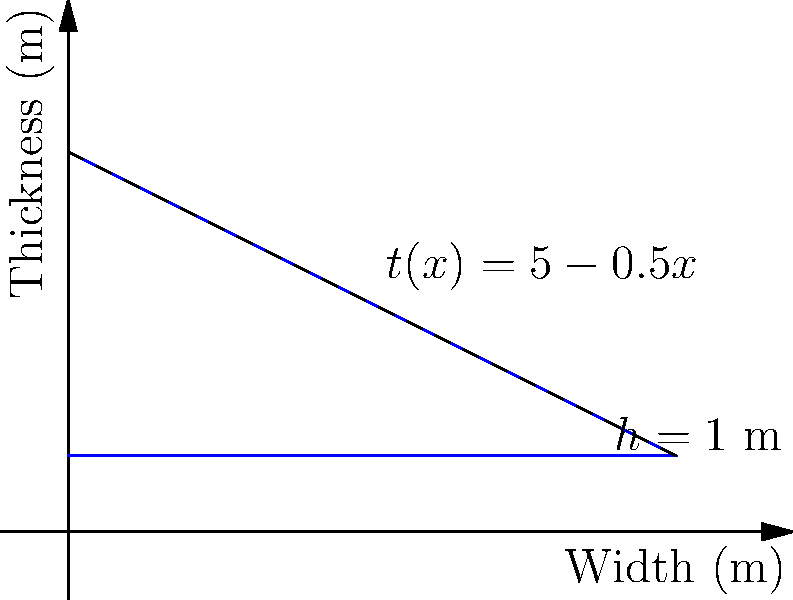A flood barrier wall has a varying thickness $t(x)$ that changes linearly from 5 m at the base to 1 m at the top, as shown in the diagram. The wall has a constant height $h$ of 1 m and a width of 8 m. If the water pressure $p$ at depth $y$ is given by $p(y) = \rho g y$, where $\rho$ is the density of water and $g$ is the acceleration due to gravity, determine the maximum bending stress $\sigma_{max}$ at the base of the wall. To find the maximum bending stress at the base of the wall, we'll follow these steps:

1) First, we need to determine the thickness function $t(x)$:
   $t(x) = 5 - 0.5x$

2) The water pressure varies linearly with depth:
   $p(y) = \rho g y$

3) The total force on the wall is the integral of pressure over the area:
   $F = \int_0^h \int_0^w \rho g y \, dx \, dy = \frac{1}{2}\rho g h^2 w$

4) The moment arm for this force is at $h/3$ from the base:
   $M = F \cdot \frac{h}{3} = \frac{1}{6}\rho g h^3 w$

5) The moment of inertia for a rectangular cross-section is:
   $I = \frac{wt^3}{12}$, where $t$ is the thickness at the base (5 m)

6) The maximum bending stress occurs at the outer fiber, which is at $t/2$ from the neutral axis:
   $\sigma_{max} = \frac{My}{I} = \frac{Mc}{I}$, where $c = t/2$

7) Substituting all values:
   $\sigma_{max} = \frac{(\frac{1}{6}\rho g h^3 w)(\frac{5}{2})}{(\frac{w5^3}{12})} = \frac{\rho g h^3}{5^2}$

8) Simplifying:
   $\sigma_{max} = \frac{\rho g}{25} = \frac{1000 \cdot 9.81}{25} = 392.4$ Pa
Answer: $\sigma_{max} = 392.4$ Pa 